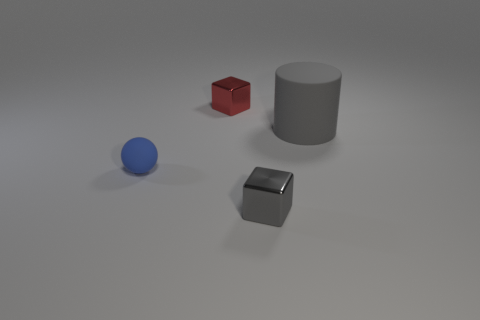Is there any other thing that has the same size as the cylinder?
Your answer should be compact. No. Is the number of large green matte blocks greater than the number of large objects?
Keep it short and to the point. No. What material is the small blue sphere?
Give a very brief answer. Rubber. There is a tiny block behind the gray matte cylinder; how many cylinders are left of it?
Provide a succinct answer. 0. Is the color of the small matte sphere the same as the small metal block in front of the red object?
Keep it short and to the point. No. What color is the rubber thing that is the same size as the gray shiny object?
Offer a terse response. Blue. Is there a big brown thing that has the same shape as the tiny red metallic object?
Give a very brief answer. No. Are there fewer gray blocks than small green blocks?
Offer a terse response. No. What is the color of the small object that is to the left of the small red shiny block?
Ensure brevity in your answer.  Blue. There is a tiny shiny thing left of the metallic thing that is in front of the big gray cylinder; what shape is it?
Make the answer very short. Cube. 